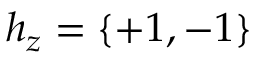<formula> <loc_0><loc_0><loc_500><loc_500>h _ { z } = \{ + 1 , - 1 \}</formula> 